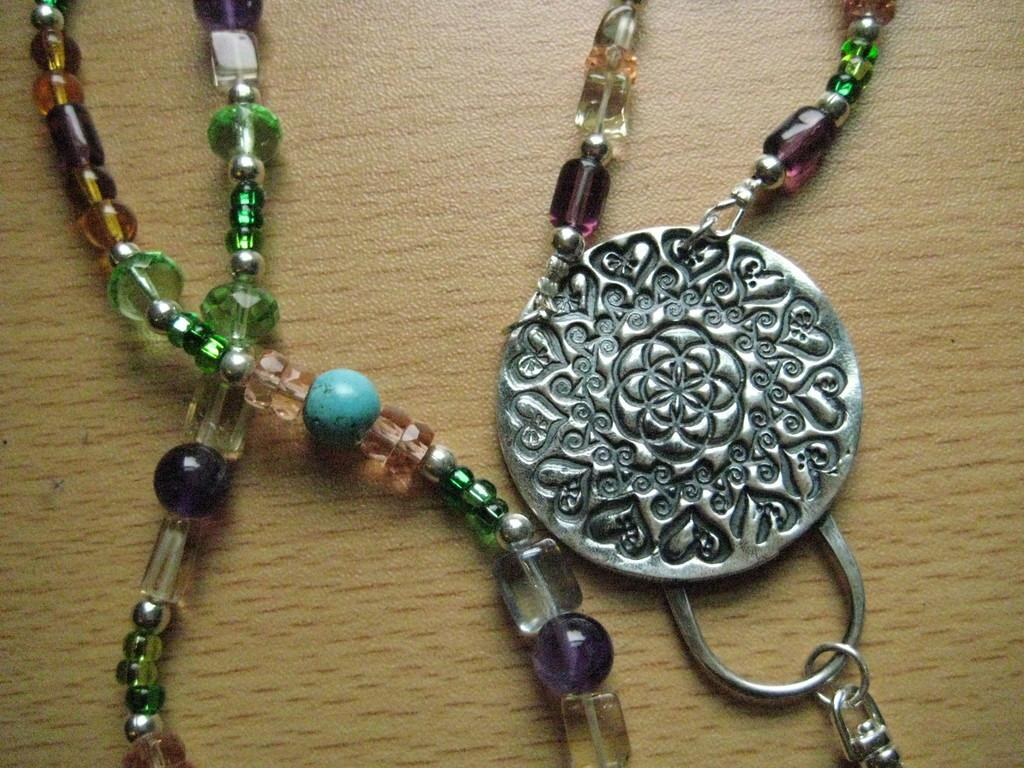What objects are present in the image? There are two colorful chains in the image. Where are the chains located? The chains are placed on a wooden table. What type of plot is being discussed by the men in the image? There are no men present in the image, and therefore no discussion or plot can be observed. What kind of loaf is being served on the table in the image? There is no loaf present in the image; only two colorful chains are visible on the wooden table. 